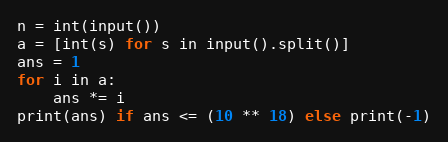<code> <loc_0><loc_0><loc_500><loc_500><_Python_>n = int(input())
a = [int(s) for s in input().split()]
ans = 1
for i in a:
    ans *= i
print(ans) if ans <= (10 ** 18) else print(-1)</code> 